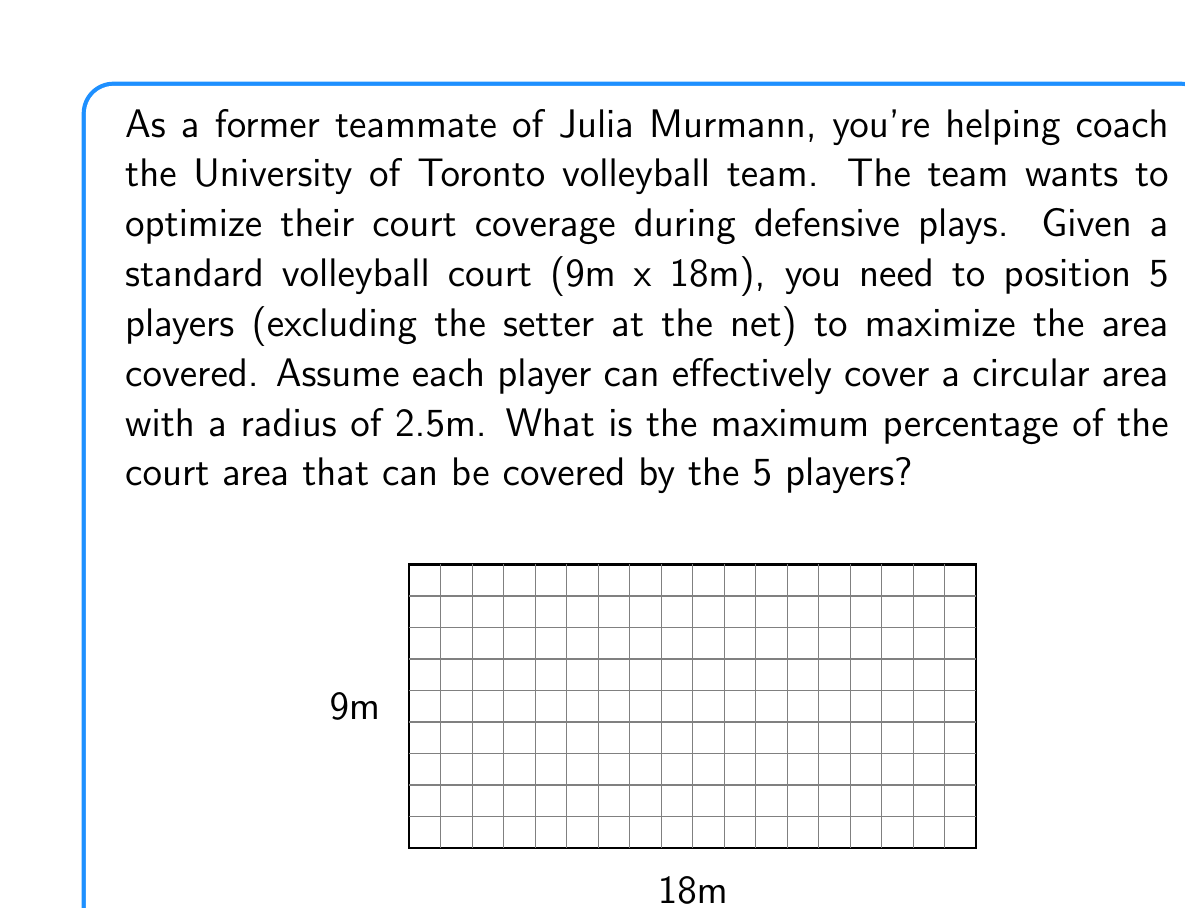Give your solution to this math problem. Let's approach this step-by-step:

1) First, calculate the total area of the volleyball court:
   $A_{court} = 9m \times 18m = 162m^2$

2) Each player covers a circular area. The area of this circle is:
   $A_{player} = \pi r^2 = \pi (2.5m)^2 = 19.63m^2$

3) To maximize coverage, we need to position the players so that their covered areas overlap as little as possible while still covering as much of the court as possible.

4) An optimal arrangement is to place four players in a square formation in the center of the court, with the fifth player in the center of this square. This forms a pattern similar to the five dots on a die.

5) In this arrangement, the four outer circles will overlap slightly with the center circle. The total area covered will be less than simply multiplying the area of one circle by 5.

6) The exact calculation of the overlapping areas is complex, but we can approximate it. Let's assume about 10% overlap, which is a reasonable estimate for this configuration.

7) So the total area covered is approximately:
   $A_{covered} \approx 5 \times 19.63m^2 \times 0.9 = 88.34m^2$

8) Now we can calculate the percentage of the court covered:
   $Percentage = \frac{A_{covered}}{A_{court}} \times 100\% = \frac{88.34m^2}{162m^2} \times 100\% \approx 54.53\%$

Therefore, the maximum percentage of the court that can be covered is approximately 54.53%.
Answer: 54.53% 